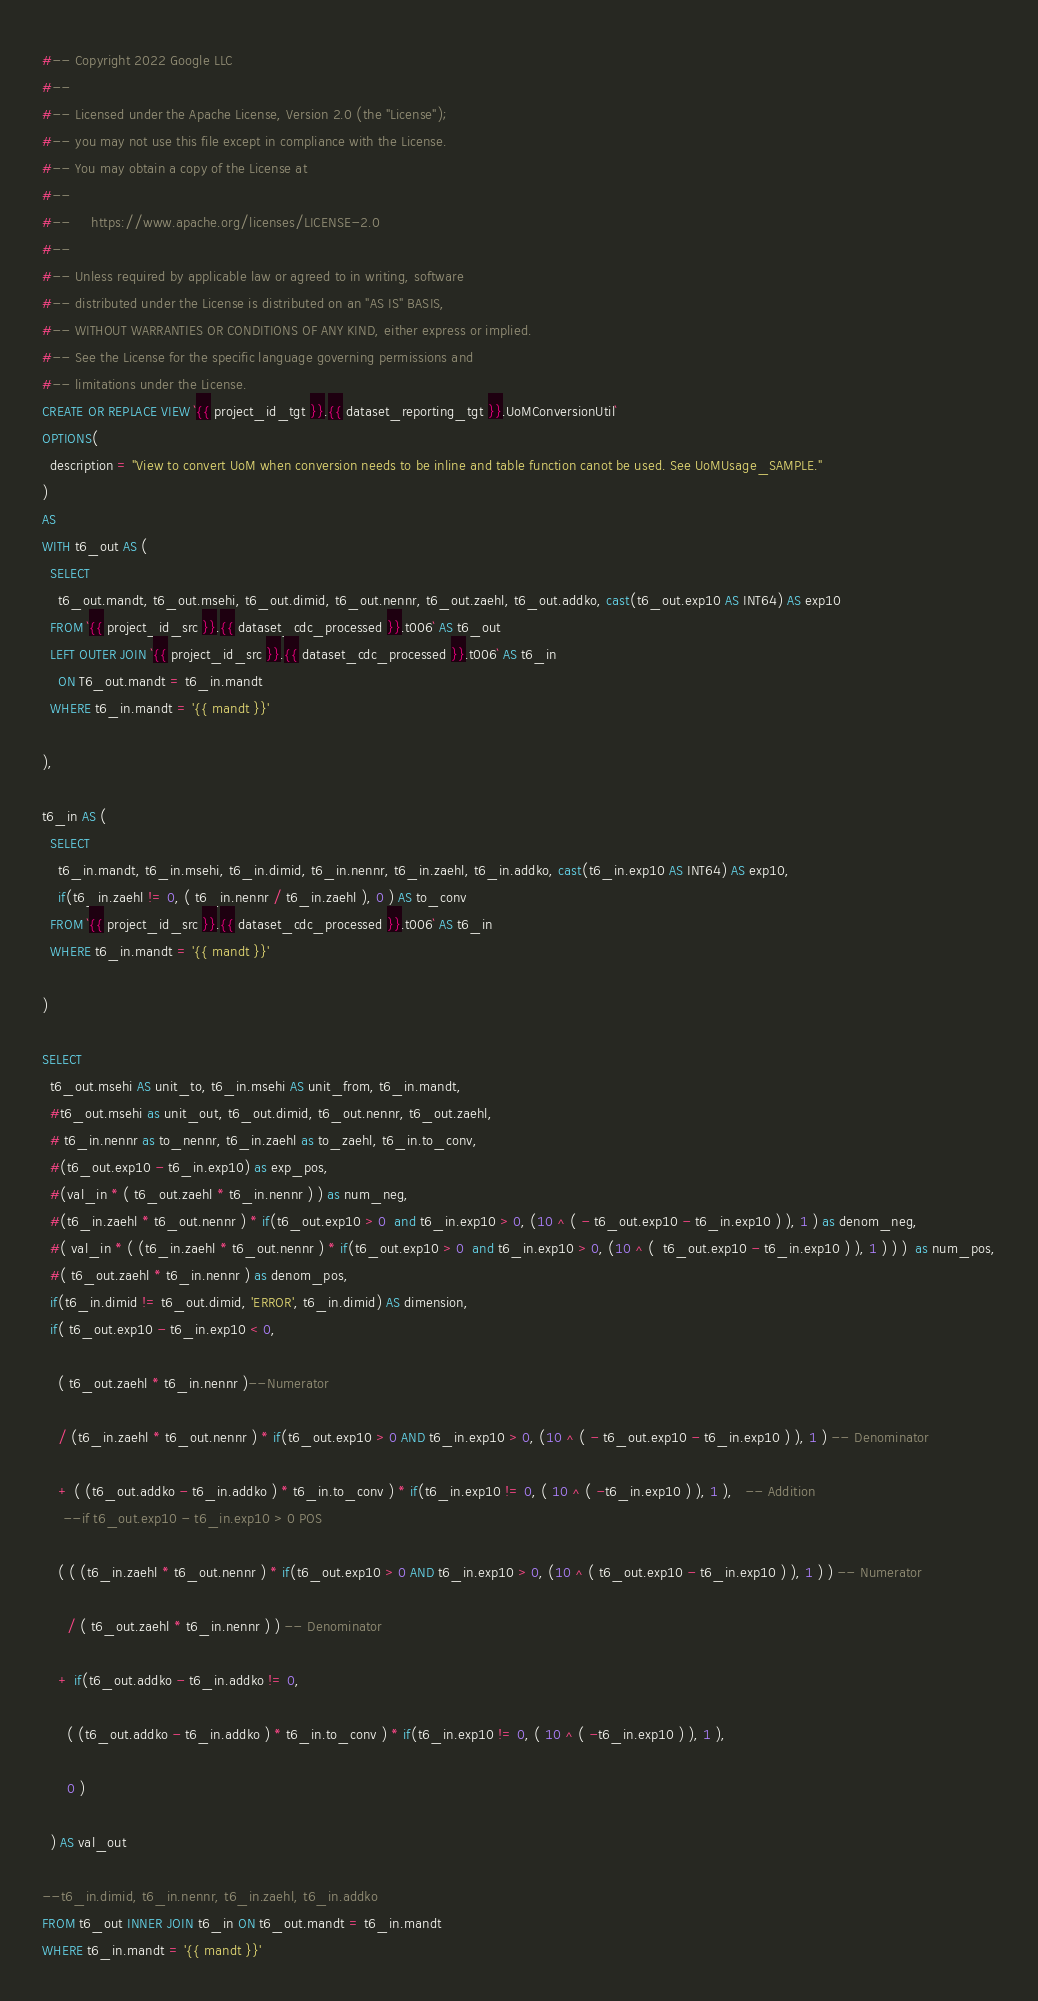Convert code to text. <code><loc_0><loc_0><loc_500><loc_500><_SQL_>#-- Copyright 2022 Google LLC
#--
#-- Licensed under the Apache License, Version 2.0 (the "License");
#-- you may not use this file except in compliance with the License.
#-- You may obtain a copy of the License at
#--
#--     https://www.apache.org/licenses/LICENSE-2.0
#--
#-- Unless required by applicable law or agreed to in writing, software
#-- distributed under the License is distributed on an "AS IS" BASIS,
#-- WITHOUT WARRANTIES OR CONDITIONS OF ANY KIND, either express or implied.
#-- See the License for the specific language governing permissions and
#-- limitations under the License.
CREATE OR REPLACE VIEW `{{ project_id_tgt }}.{{ dataset_reporting_tgt }}.UoMConversionUtil`
OPTIONS(
  description = "View to convert UoM when conversion needs to be inline and table function canot be used. See UoMUsage_SAMPLE."
)
AS
WITH t6_out AS (
  SELECT
    t6_out.mandt, t6_out.msehi, t6_out.dimid, t6_out.nennr, t6_out.zaehl, t6_out.addko, cast(t6_out.exp10 AS INT64) AS exp10
  FROM `{{ project_id_src }}.{{ dataset_cdc_processed }}.t006` AS t6_out
  LEFT OUTER JOIN `{{ project_id_src }}.{{ dataset_cdc_processed }}.t006` AS t6_in
    ON T6_out.mandt = t6_in.mandt
  WHERE t6_in.mandt = '{{ mandt }}'

),

t6_in AS (
  SELECT
    t6_in.mandt, t6_in.msehi, t6_in.dimid, t6_in.nennr, t6_in.zaehl, t6_in.addko, cast(t6_in.exp10 AS INT64) AS exp10,
    if(t6_in.zaehl != 0, ( t6_in.nennr / t6_in.zaehl ), 0 ) AS to_conv
  FROM `{{ project_id_src }}.{{ dataset_cdc_processed }}.t006` AS t6_in
  WHERE t6_in.mandt = '{{ mandt }}'

)

SELECT
  t6_out.msehi AS unit_to, t6_in.msehi AS unit_from, t6_in.mandt,
  #t6_out.msehi as unit_out, t6_out.dimid, t6_out.nennr, t6_out.zaehl, 
  # t6_in.nennr as to_nennr, t6_in.zaehl as to_zaehl, t6_in.to_conv, 
  #(t6_out.exp10 - t6_in.exp10) as exp_pos, 
  #(val_in * ( t6_out.zaehl * t6_in.nennr ) ) as num_neg,
  #(t6_in.zaehl * t6_out.nennr ) * if(t6_out.exp10 > 0  and t6_in.exp10 > 0, (10 ^ ( - t6_out.exp10 - t6_in.exp10 ) ), 1 ) as denom_neg,
  #( val_in * ( (t6_in.zaehl * t6_out.nennr ) * if(t6_out.exp10 > 0  and t6_in.exp10 > 0, (10 ^ (  t6_out.exp10 - t6_in.exp10 ) ), 1 ) ) )  as num_pos,
  #( t6_out.zaehl * t6_in.nennr ) as denom_pos,
  if(t6_in.dimid != t6_out.dimid, 'ERROR', t6_in.dimid) AS dimension,
  if( t6_out.exp10 - t6_in.exp10 < 0,

    ( t6_out.zaehl * t6_in.nennr )--Numerator

    / (t6_in.zaehl * t6_out.nennr ) * if(t6_out.exp10 > 0 AND t6_in.exp10 > 0, (10 ^ ( - t6_out.exp10 - t6_in.exp10 ) ), 1 ) -- Denominator

    + ( (t6_out.addko - t6_in.addko ) * t6_in.to_conv ) * if(t6_in.exp10 != 0, ( 10 ^ ( -t6_in.exp10 ) ), 1 ),   -- Addition 
     --if t6_out.exp10 - t6_in.exp10 > 0 POS

    ( ( (t6_in.zaehl * t6_out.nennr ) * if(t6_out.exp10 > 0 AND t6_in.exp10 > 0, (10 ^ ( t6_out.exp10 - t6_in.exp10 ) ), 1 ) ) -- Numerator

      / ( t6_out.zaehl * t6_in.nennr ) ) -- Denominator 

    + if(t6_out.addko - t6_in.addko != 0,

      ( (t6_out.addko - t6_in.addko ) * t6_in.to_conv ) * if(t6_in.exp10 != 0, ( 10 ^ ( -t6_in.exp10 ) ), 1 ),

      0 )

  ) AS val_out

--t6_in.dimid, t6_in.nennr, t6_in.zaehl, t6_in.addko 
FROM t6_out INNER JOIN t6_in ON t6_out.mandt = t6_in.mandt
WHERE t6_in.mandt = '{{ mandt }}'
</code> 